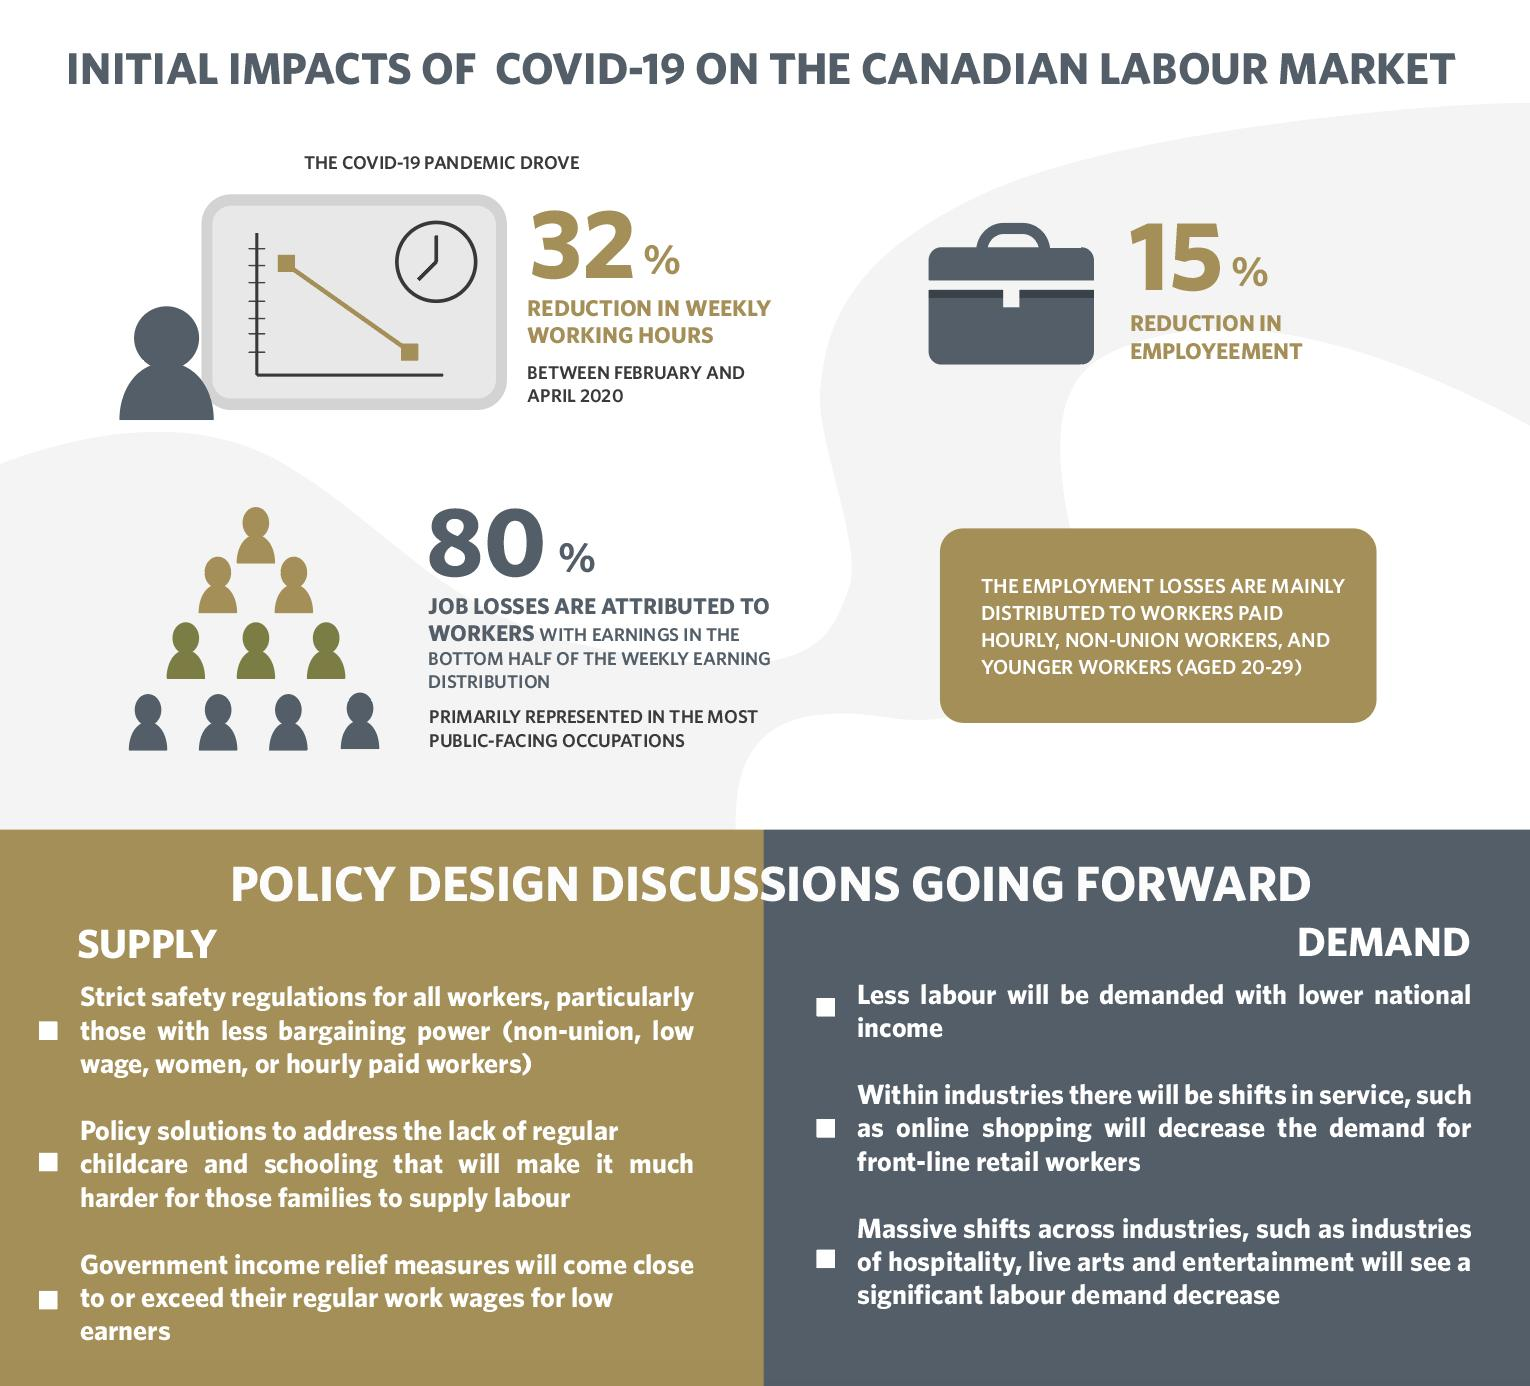Mention a couple of crucial points in this snapshot. The impact of COVID-19 on the Canadian labour market resulted in a 15% reduction in employment. 